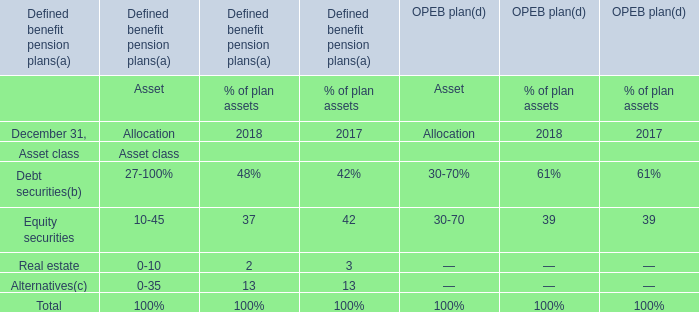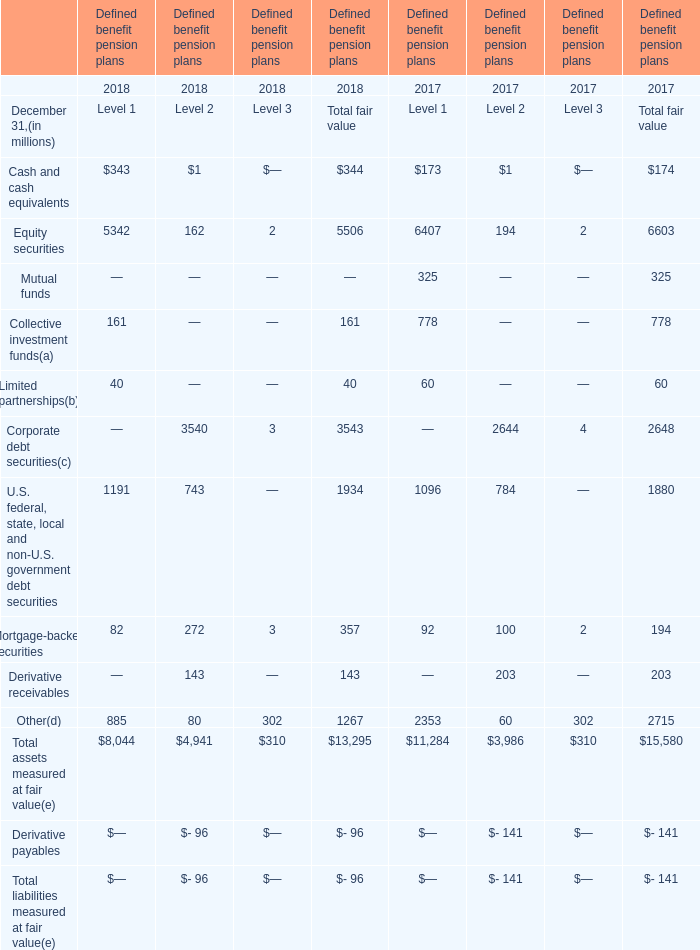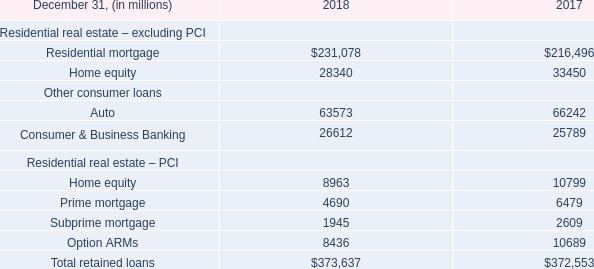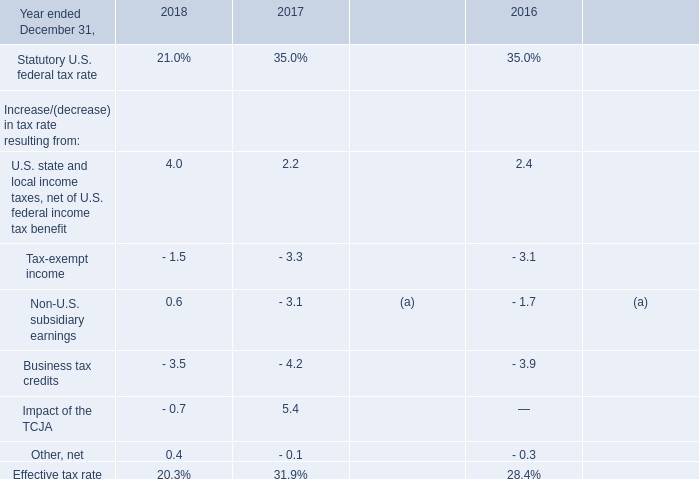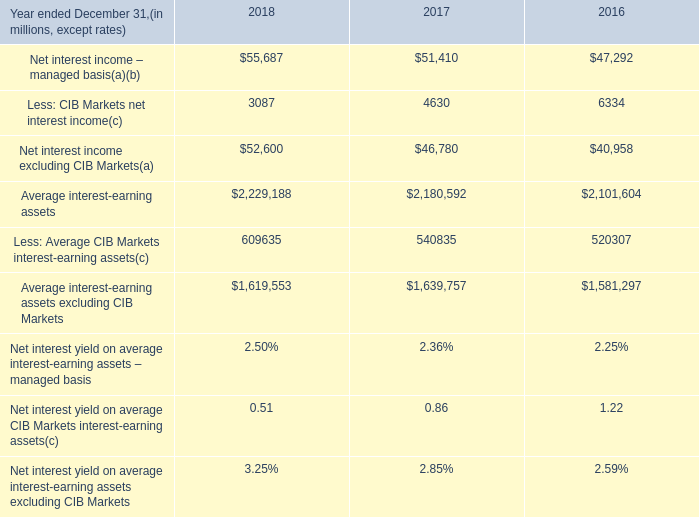What is the growth rate of the fair value of the Corporate debt securities of Level 2 between 2017 and 2018? 
Computations: ((3540 - 2644) / 2644)
Answer: 0.33888. 